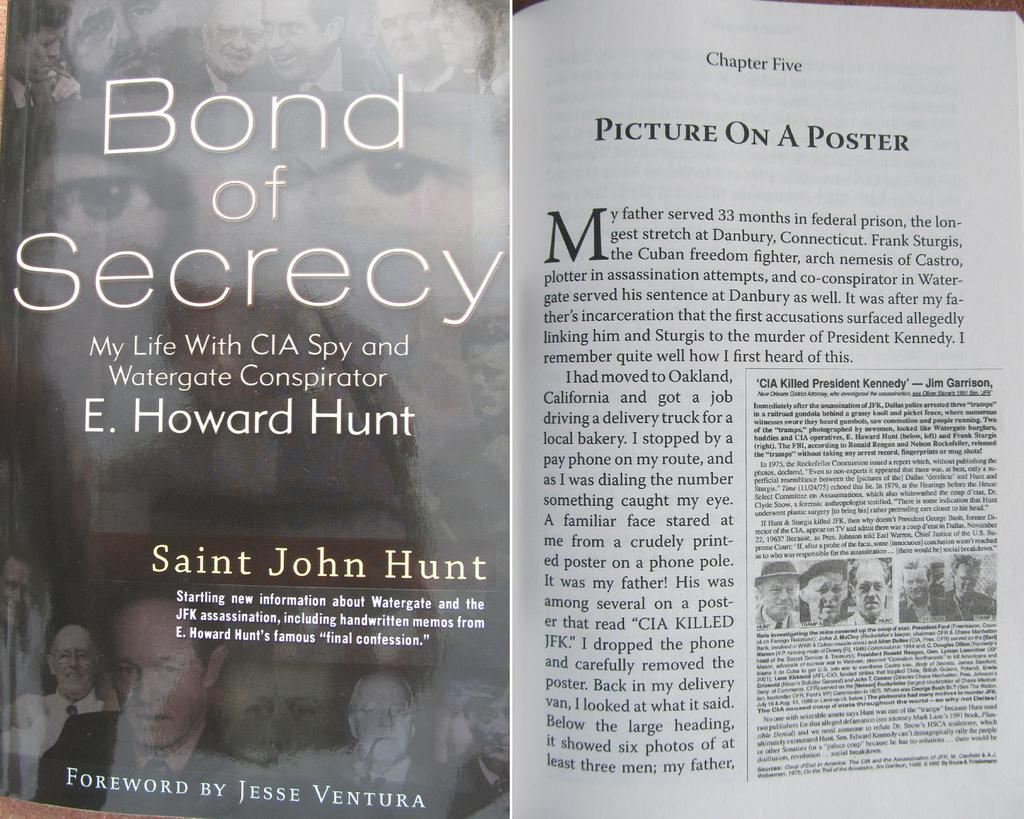What is the main object in the image? There is a book in the image. What can be found inside the book? The book contains text and images. Where can the shelf with the book be found in the image? There is no shelf mentioned in the facts, and the image does not show a shelf. Can you see the seashore in the background of the image? There is no mention of a seashore in the facts, and the image does not show a seashore. 